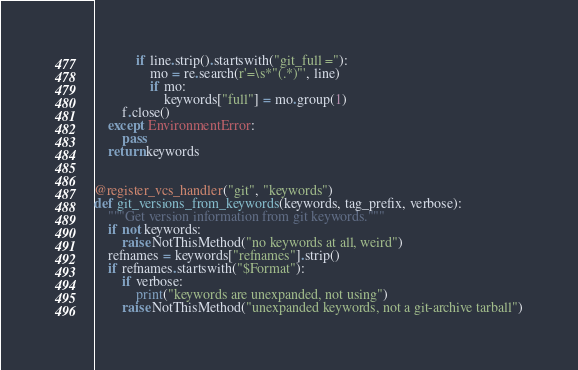Convert code to text. <code><loc_0><loc_0><loc_500><loc_500><_Python_>            if line.strip().startswith("git_full ="):
                mo = re.search(r'=\s*"(.*)"', line)
                if mo:
                    keywords["full"] = mo.group(1)
        f.close()
    except EnvironmentError:
        pass
    return keywords


@register_vcs_handler("git", "keywords")
def git_versions_from_keywords(keywords, tag_prefix, verbose):
    """Get version information from git keywords."""
    if not keywords:
        raise NotThisMethod("no keywords at all, weird")
    refnames = keywords["refnames"].strip()
    if refnames.startswith("$Format"):
        if verbose:
            print("keywords are unexpanded, not using")
        raise NotThisMethod("unexpanded keywords, not a git-archive tarball")</code> 